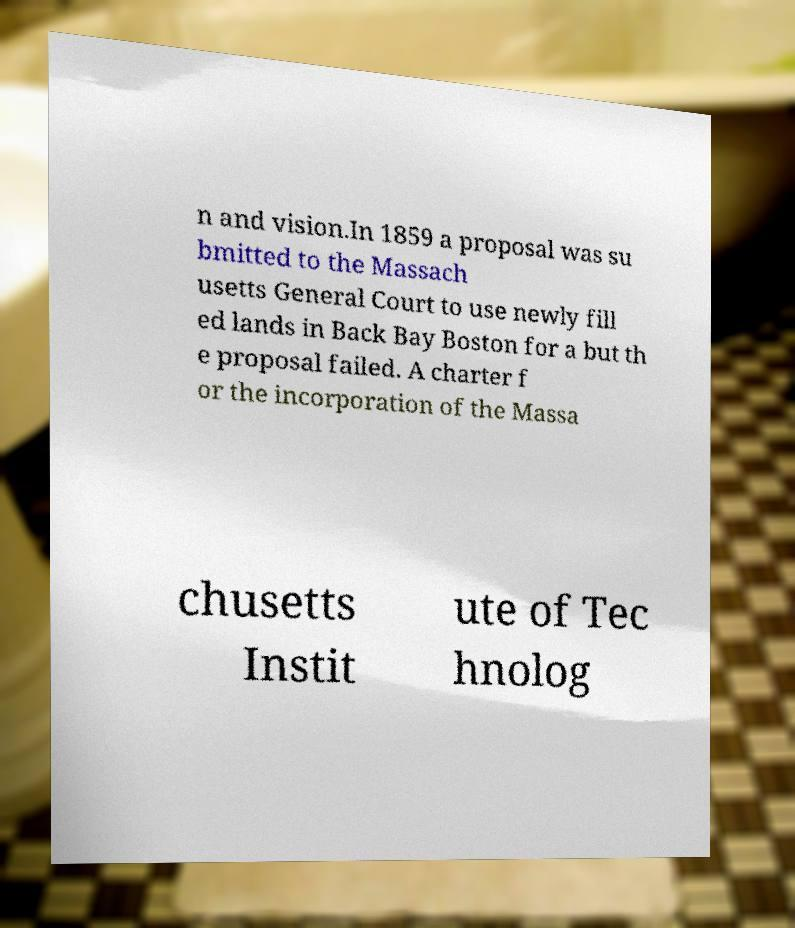Can you read and provide the text displayed in the image?This photo seems to have some interesting text. Can you extract and type it out for me? n and vision.In 1859 a proposal was su bmitted to the Massach usetts General Court to use newly fill ed lands in Back Bay Boston for a but th e proposal failed. A charter f or the incorporation of the Massa chusetts Instit ute of Tec hnolog 